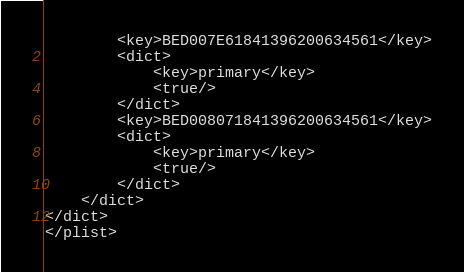<code> <loc_0><loc_0><loc_500><loc_500><_XML_>		<key>BED007E61841396200634561</key>
		<dict>
			<key>primary</key>
			<true/>
		</dict>
		<key>BED008071841396200634561</key>
		<dict>
			<key>primary</key>
			<true/>
		</dict>
	</dict>
</dict>
</plist>
</code> 